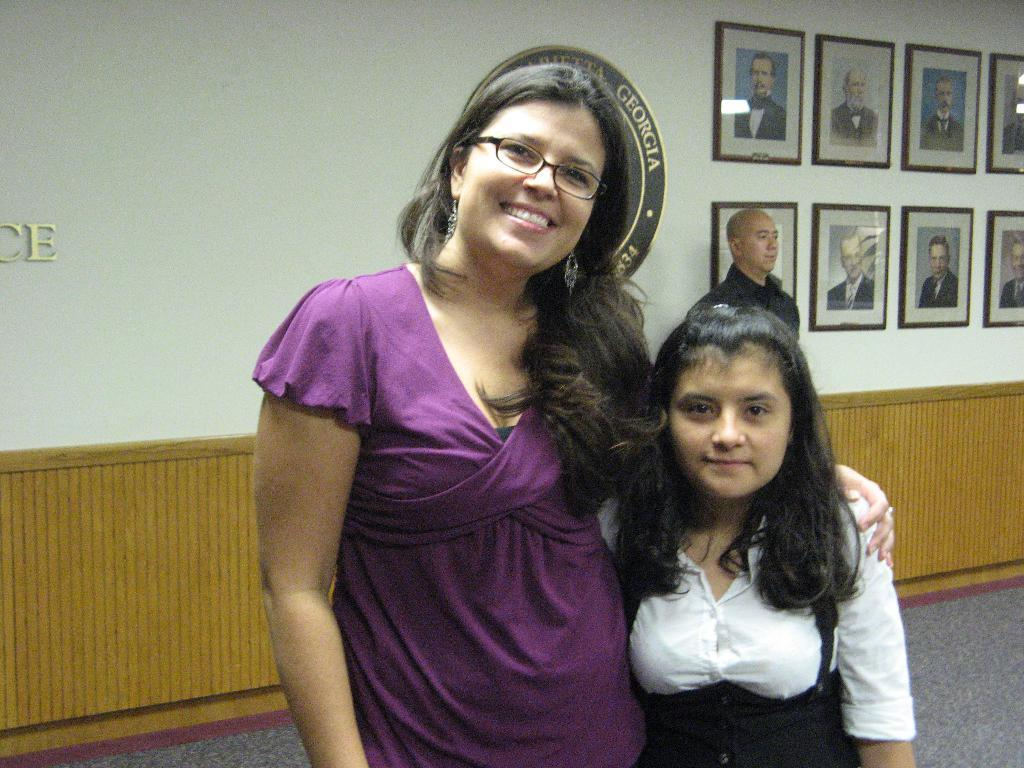Who are the people in the image? There is there a lady and a girl in the image? Where are the lady and the girl located in the image? The lady and the girl are in the center of the image. Is there a man in the image? Yes, there is a man in the image. Where is the man positioned in relation to the lady and the girl? The man is behind the lady and the girl. What can be seen in the background of the image? There are photographs on the wall in the background of the image. Can you see a snake slithering on the floor in the image? No, there is no snake present in the image. How many ladybugs are crawling on the lady's shoulder in the image? There are no ladybugs present in the image. 